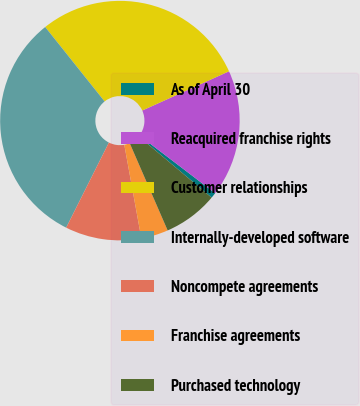Convert chart to OTSL. <chart><loc_0><loc_0><loc_500><loc_500><pie_chart><fcel>As of April 30<fcel>Reacquired franchise rights<fcel>Customer relationships<fcel>Internally-developed software<fcel>Noncompete agreements<fcel>Franchise agreements<fcel>Purchased technology<nl><fcel>0.75%<fcel>17.12%<fcel>28.97%<fcel>31.88%<fcel>10.27%<fcel>3.66%<fcel>7.36%<nl></chart> 